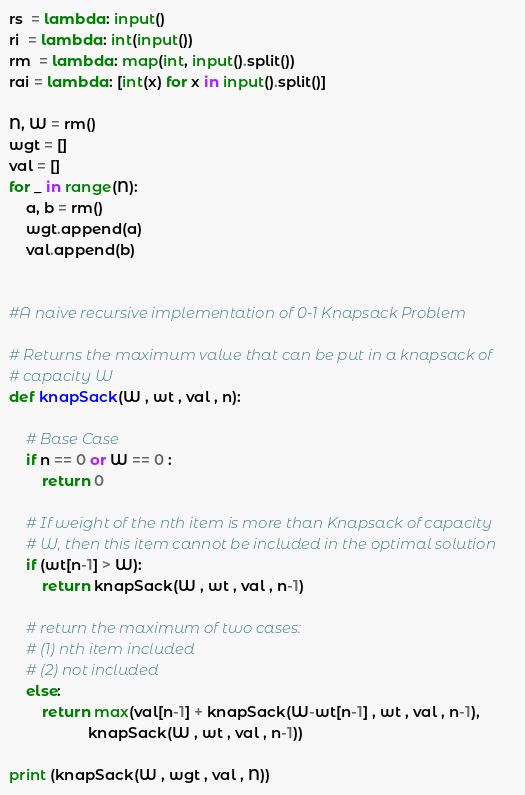Convert code to text. <code><loc_0><loc_0><loc_500><loc_500><_Python_>rs  = lambda: input()
ri  = lambda: int(input())
rm  = lambda: map(int, input().split())
rai = lambda: [int(x) for x in input().split()]

N, W = rm()  
wgt = []
val = []      
for _ in range(N):
    a, b = rm()
    wgt.append(a)
    val.append(b)


#A naive recursive implementation of 0-1 Knapsack Problem 
  
# Returns the maximum value that can be put in a knapsack of 
# capacity W 
def knapSack(W , wt , val , n): 
  
    # Base Case 
    if n == 0 or W == 0 : 
        return 0
  
    # If weight of the nth item is more than Knapsack of capacity 
    # W, then this item cannot be included in the optimal solution 
    if (wt[n-1] > W): 
        return knapSack(W , wt , val , n-1) 
  
    # return the maximum of two cases: 
    # (1) nth item included 
    # (2) not included 
    else: 
        return max(val[n-1] + knapSack(W-wt[n-1] , wt , val , n-1), 
                   knapSack(W , wt , val , n-1)) 

print (knapSack(W , wgt , val , N))</code> 